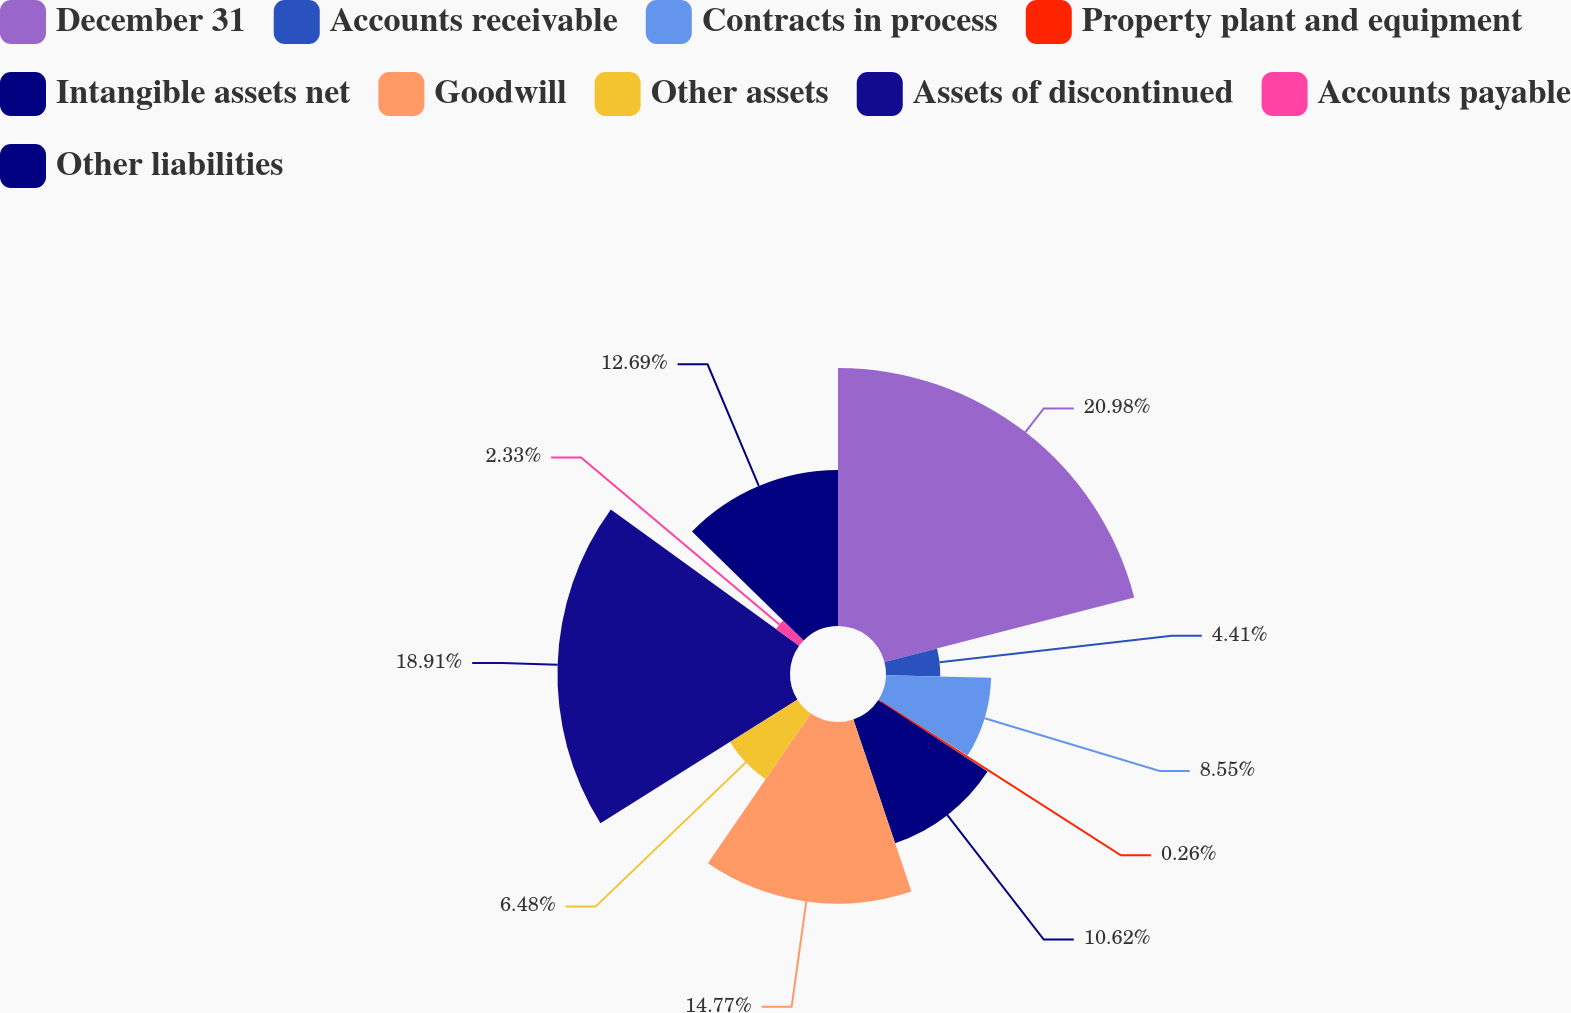Convert chart. <chart><loc_0><loc_0><loc_500><loc_500><pie_chart><fcel>December 31<fcel>Accounts receivable<fcel>Contracts in process<fcel>Property plant and equipment<fcel>Intangible assets net<fcel>Goodwill<fcel>Other assets<fcel>Assets of discontinued<fcel>Accounts payable<fcel>Other liabilities<nl><fcel>20.98%<fcel>4.41%<fcel>8.55%<fcel>0.26%<fcel>10.62%<fcel>14.77%<fcel>6.48%<fcel>18.91%<fcel>2.33%<fcel>12.69%<nl></chart> 